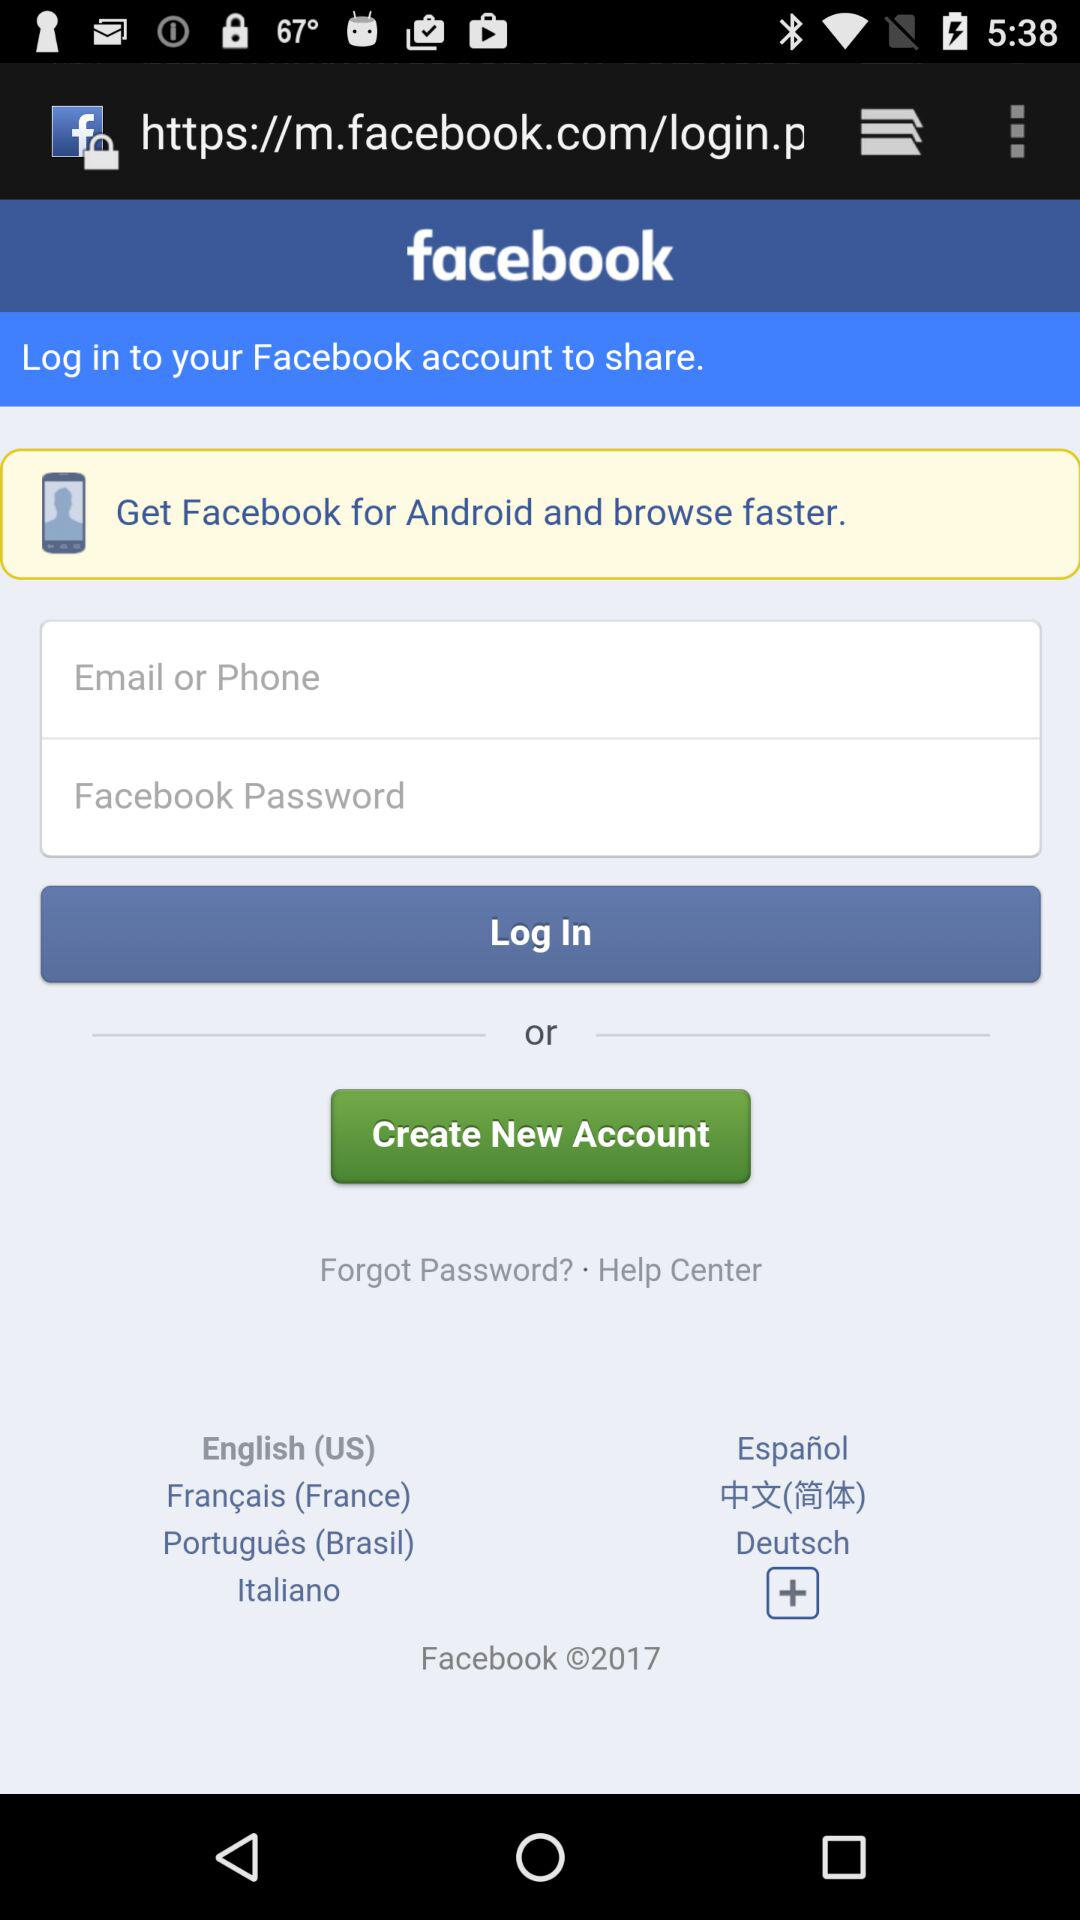What is the selected language? The selected language is English (US). 